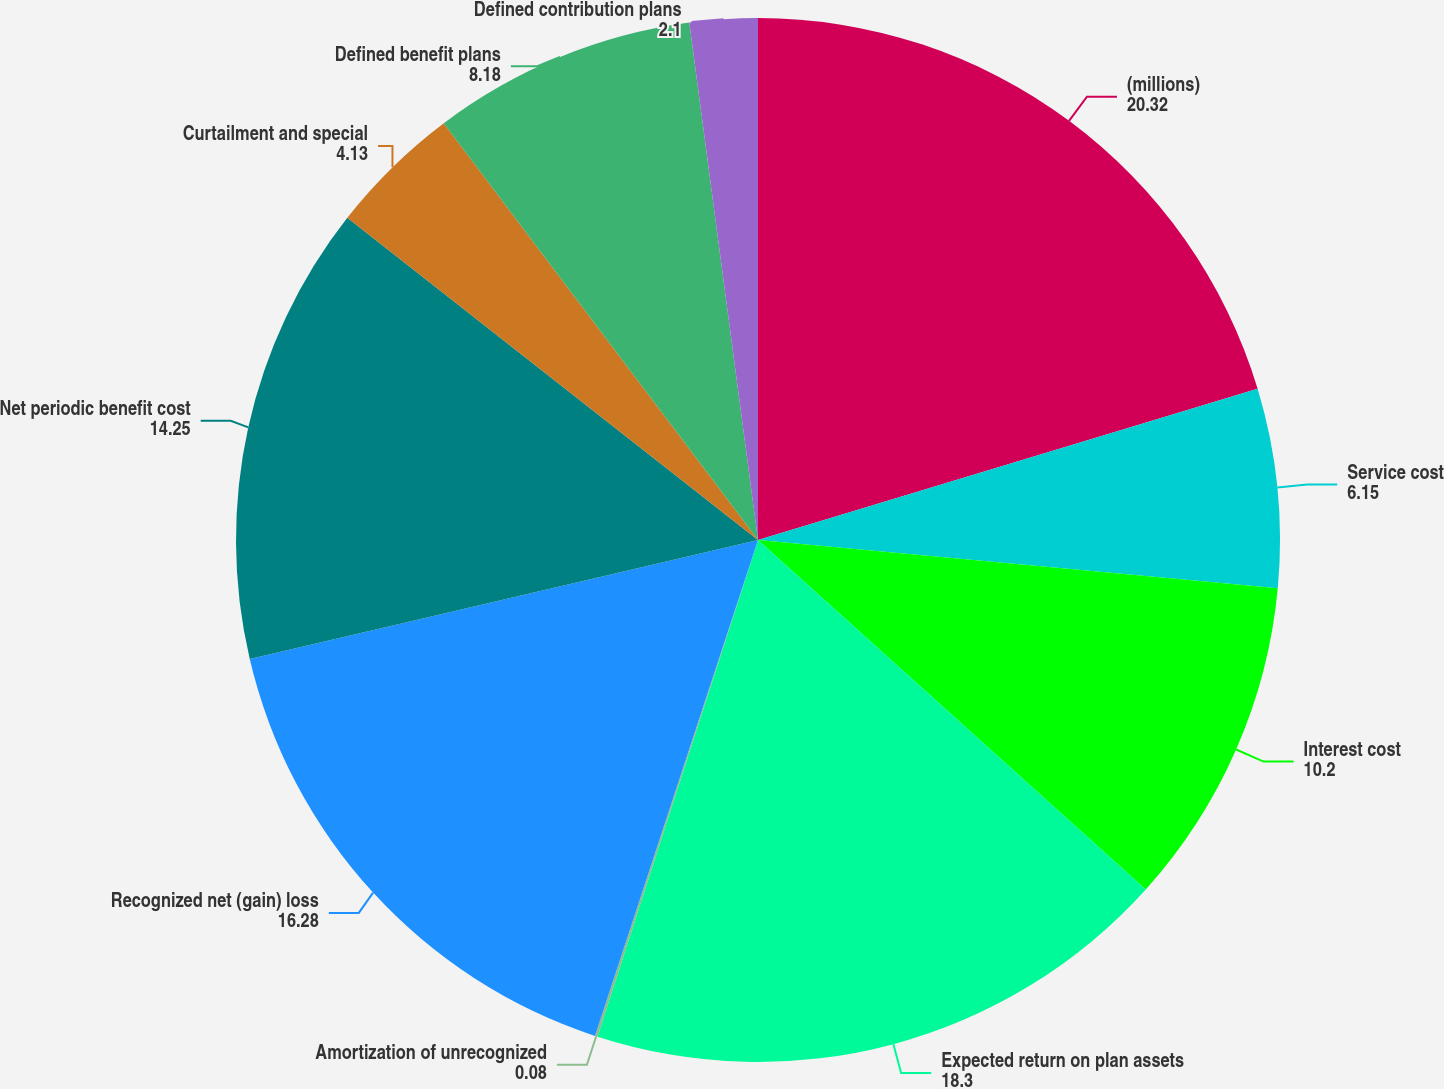Convert chart to OTSL. <chart><loc_0><loc_0><loc_500><loc_500><pie_chart><fcel>(millions)<fcel>Service cost<fcel>Interest cost<fcel>Expected return on plan assets<fcel>Amortization of unrecognized<fcel>Recognized net (gain) loss<fcel>Net periodic benefit cost<fcel>Curtailment and special<fcel>Defined benefit plans<fcel>Defined contribution plans<nl><fcel>20.32%<fcel>6.15%<fcel>10.2%<fcel>18.3%<fcel>0.08%<fcel>16.28%<fcel>14.25%<fcel>4.13%<fcel>8.18%<fcel>2.1%<nl></chart> 